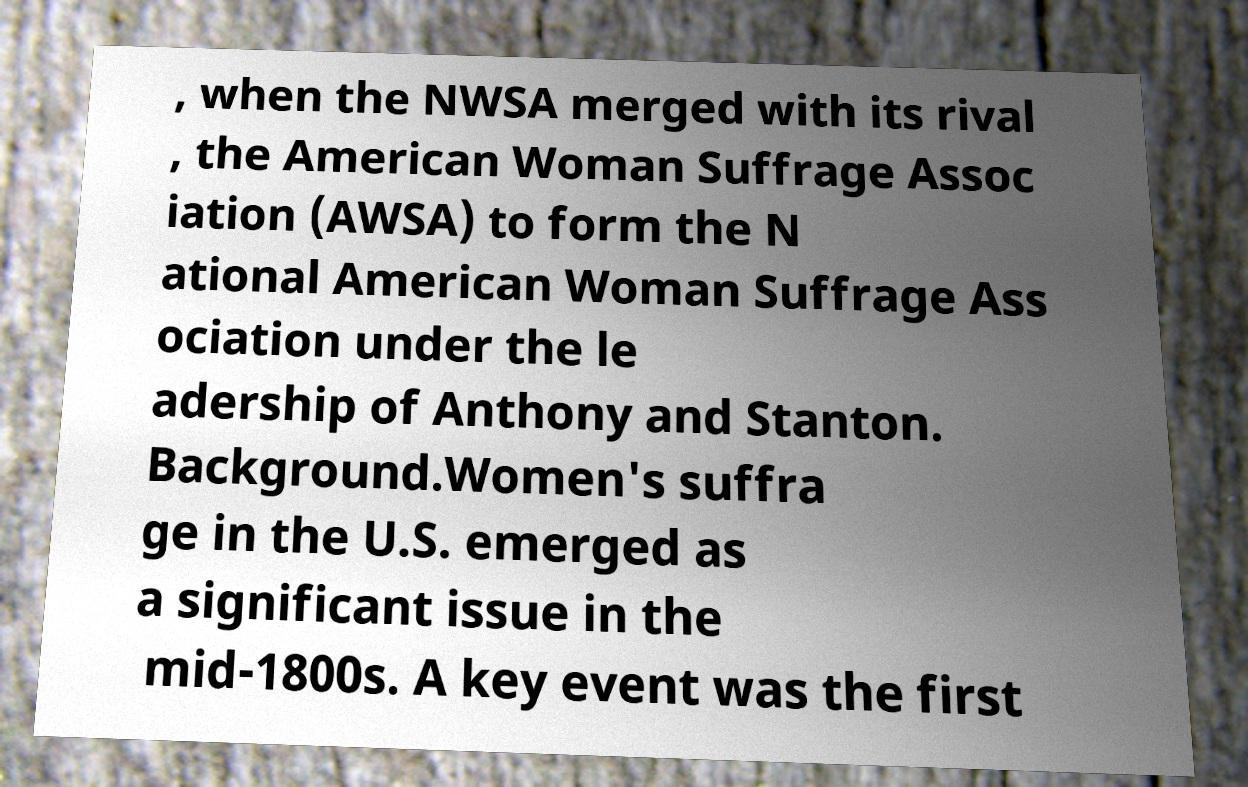Please identify and transcribe the text found in this image. , when the NWSA merged with its rival , the American Woman Suffrage Assoc iation (AWSA) to form the N ational American Woman Suffrage Ass ociation under the le adership of Anthony and Stanton. Background.Women's suffra ge in the U.S. emerged as a significant issue in the mid-1800s. A key event was the first 